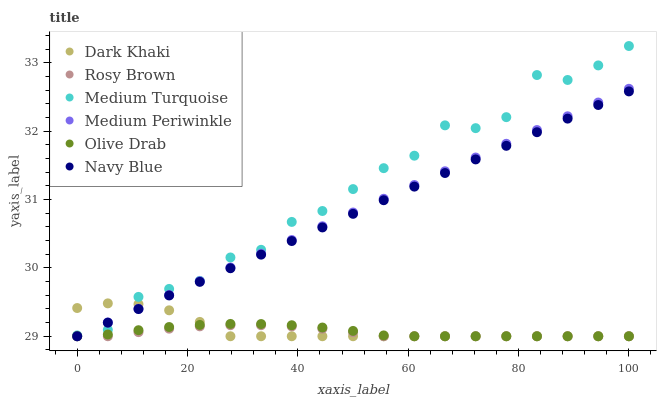Does Rosy Brown have the minimum area under the curve?
Answer yes or no. Yes. Does Medium Turquoise have the maximum area under the curve?
Answer yes or no. Yes. Does Medium Periwinkle have the minimum area under the curve?
Answer yes or no. No. Does Medium Periwinkle have the maximum area under the curve?
Answer yes or no. No. Is Navy Blue the smoothest?
Answer yes or no. Yes. Is Medium Turquoise the roughest?
Answer yes or no. Yes. Is Rosy Brown the smoothest?
Answer yes or no. No. Is Rosy Brown the roughest?
Answer yes or no. No. Does Navy Blue have the lowest value?
Answer yes or no. Yes. Does Medium Turquoise have the lowest value?
Answer yes or no. No. Does Medium Turquoise have the highest value?
Answer yes or no. Yes. Does Medium Periwinkle have the highest value?
Answer yes or no. No. Is Olive Drab less than Medium Turquoise?
Answer yes or no. Yes. Is Medium Turquoise greater than Olive Drab?
Answer yes or no. Yes. Does Navy Blue intersect Olive Drab?
Answer yes or no. Yes. Is Navy Blue less than Olive Drab?
Answer yes or no. No. Is Navy Blue greater than Olive Drab?
Answer yes or no. No. Does Olive Drab intersect Medium Turquoise?
Answer yes or no. No. 